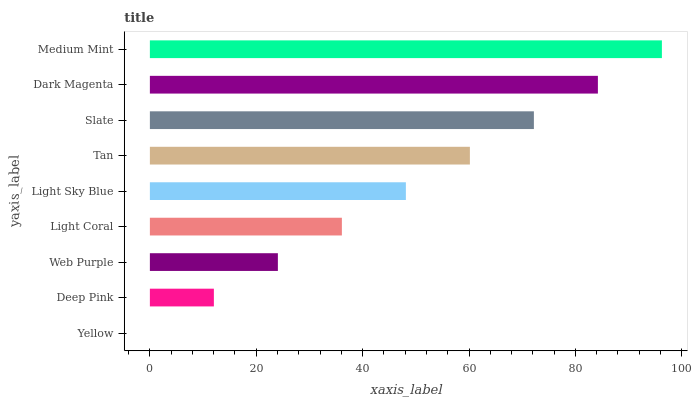Is Yellow the minimum?
Answer yes or no. Yes. Is Medium Mint the maximum?
Answer yes or no. Yes. Is Deep Pink the minimum?
Answer yes or no. No. Is Deep Pink the maximum?
Answer yes or no. No. Is Deep Pink greater than Yellow?
Answer yes or no. Yes. Is Yellow less than Deep Pink?
Answer yes or no. Yes. Is Yellow greater than Deep Pink?
Answer yes or no. No. Is Deep Pink less than Yellow?
Answer yes or no. No. Is Light Sky Blue the high median?
Answer yes or no. Yes. Is Light Sky Blue the low median?
Answer yes or no. Yes. Is Tan the high median?
Answer yes or no. No. Is Web Purple the low median?
Answer yes or no. No. 